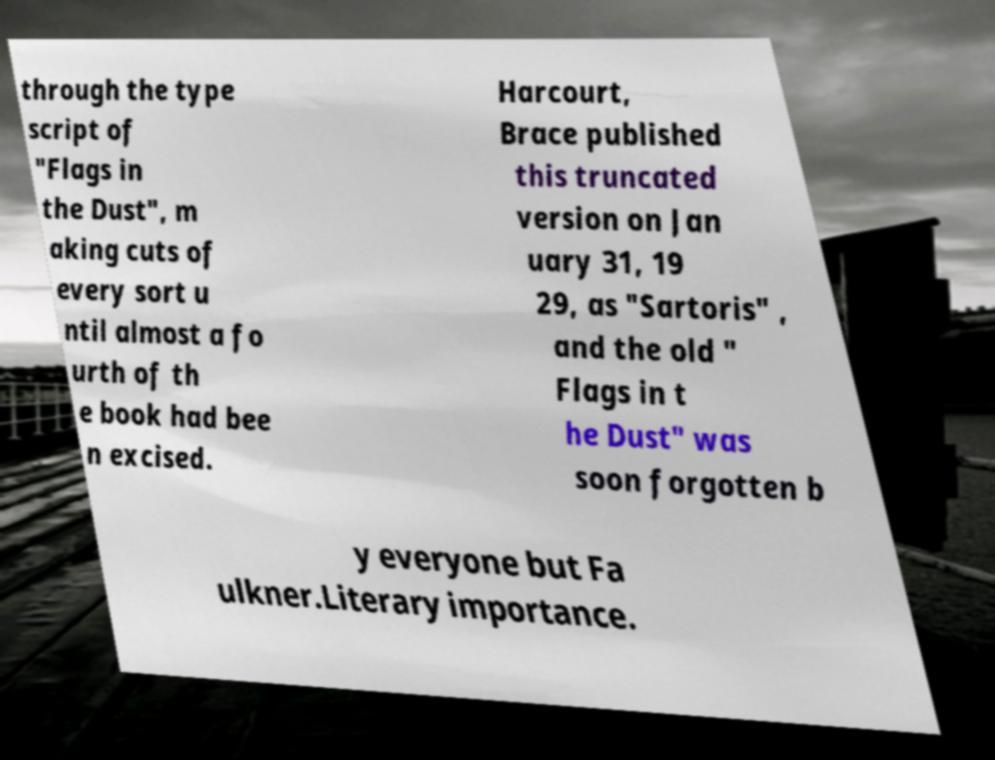Can you read and provide the text displayed in the image?This photo seems to have some interesting text. Can you extract and type it out for me? through the type script of "Flags in the Dust", m aking cuts of every sort u ntil almost a fo urth of th e book had bee n excised. Harcourt, Brace published this truncated version on Jan uary 31, 19 29, as "Sartoris" , and the old " Flags in t he Dust" was soon forgotten b y everyone but Fa ulkner.Literary importance. 